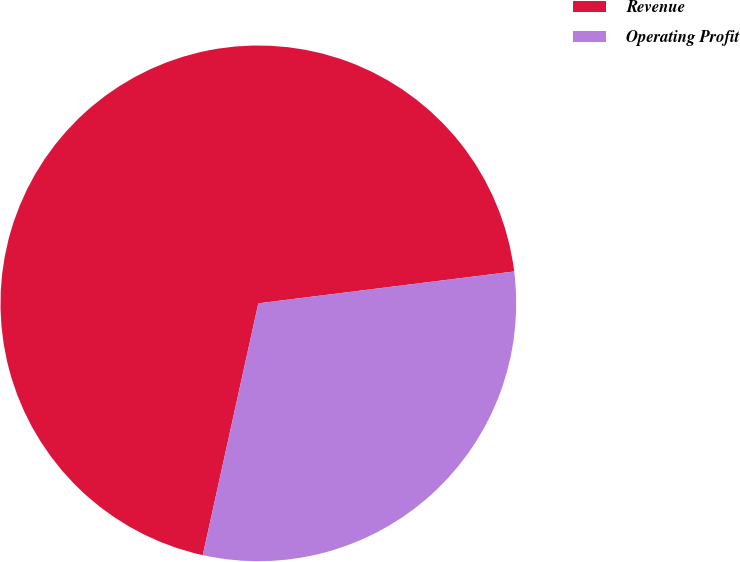Convert chart to OTSL. <chart><loc_0><loc_0><loc_500><loc_500><pie_chart><fcel>Revenue<fcel>Operating Profit<nl><fcel>69.57%<fcel>30.43%<nl></chart> 